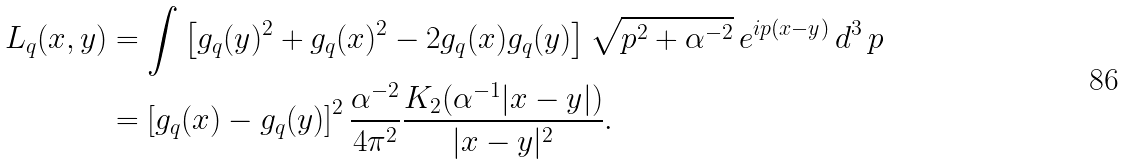Convert formula to latex. <formula><loc_0><loc_0><loc_500><loc_500>L _ { q } ( x , y ) & = \int \left [ g _ { q } ( y ) ^ { 2 } + g _ { q } ( x ) ^ { 2 } - 2 g _ { q } ( x ) g _ { q } ( y ) \right ] \sqrt { p ^ { 2 } + \alpha ^ { - 2 } } \, e ^ { i p ( x - y ) } \, d ^ { 3 } \, p \\ & = \left [ g _ { q } ( x ) - g _ { q } ( y ) \right ] ^ { 2 } \frac { \alpha ^ { - 2 } } { 4 \pi ^ { 2 } } \frac { K _ { 2 } ( \alpha ^ { - 1 } | x - y | ) } { | x - y | ^ { 2 } } .</formula> 